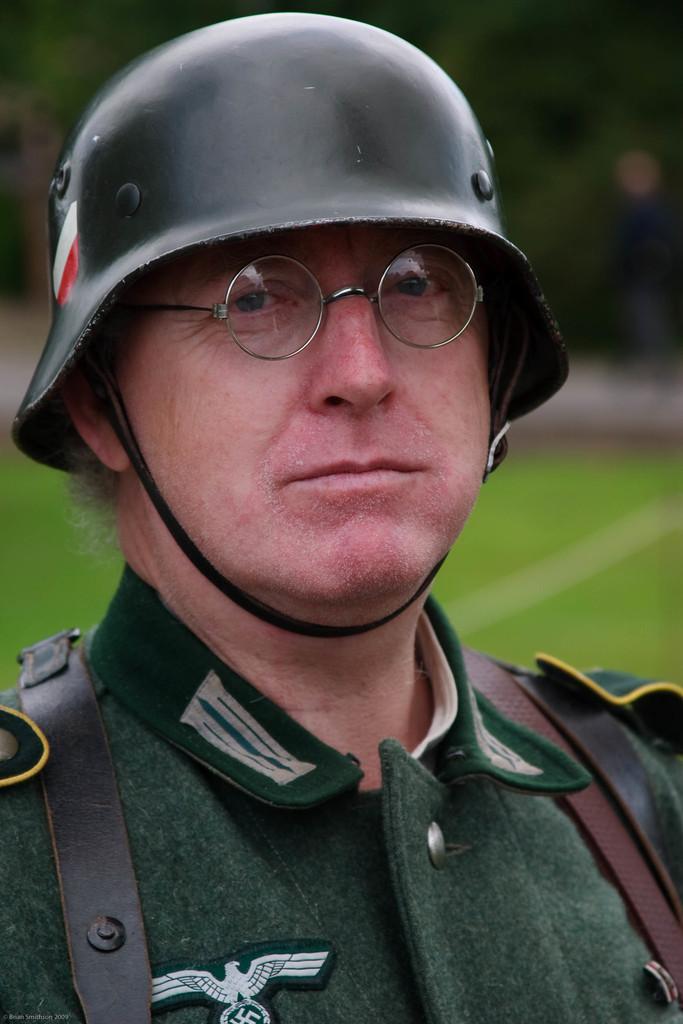Could you give a brief overview of what you see in this image? In this image we can see a person. A person is wearing the helmet. There is a grassy land in the image. There are few trees in the image. 